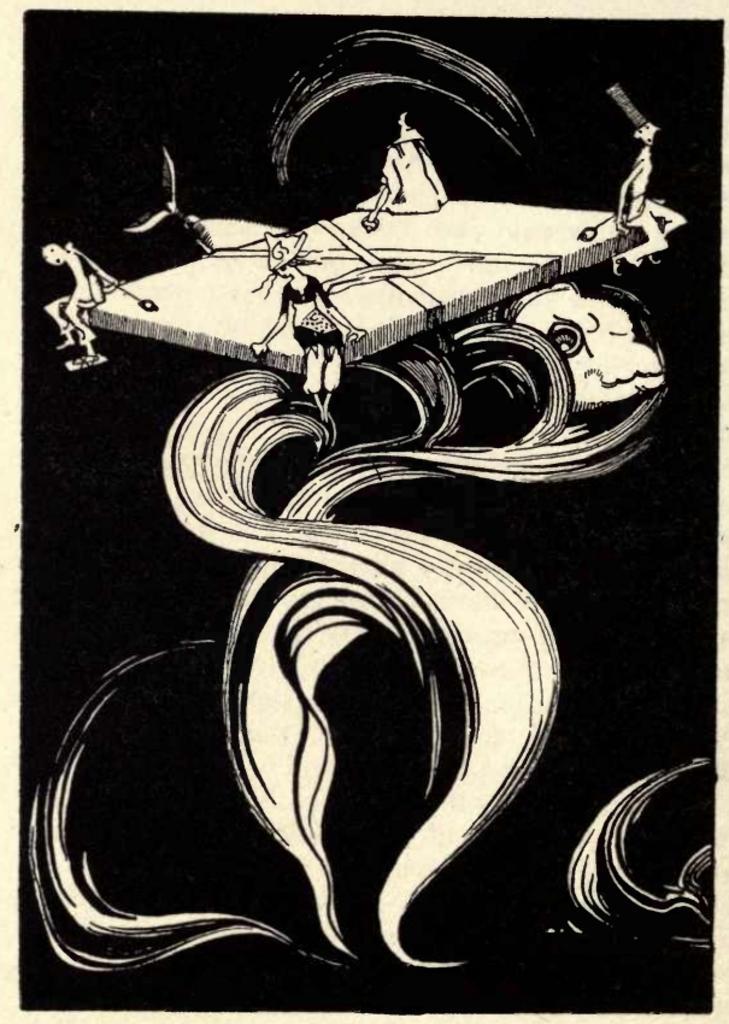In one or two sentences, can you explain what this image depicts? In this picture we can observe a white color painting on the black color background. We can observe four people sitting on the four corners of surface. We can observe a fish. 